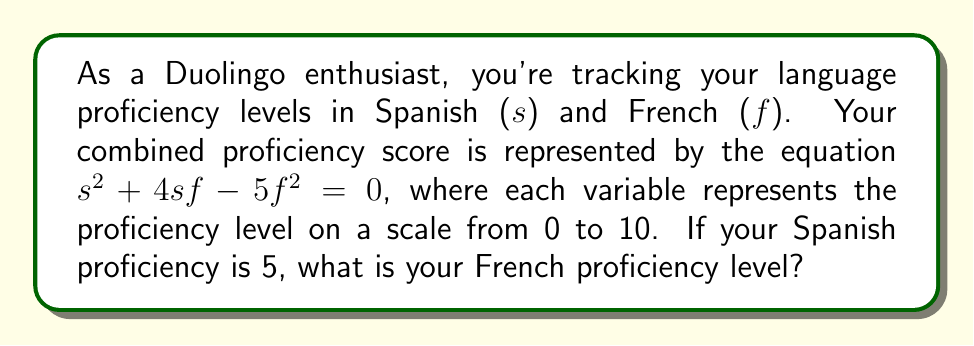Give your solution to this math problem. Let's solve this step-by-step:

1) We're given that $s = 5$ (Spanish proficiency), and we need to find $f$ (French proficiency).

2) Substitute $s = 5$ into the equation:
   $$(5)^2 + 4(5)f - 5f^2 = 0$$

3) Simplify:
   $$25 + 20f - 5f^2 = 0$$

4) Rearrange to standard form:
   $$-5f^2 + 20f + 25 = 0$$

5) Divide everything by -5 to make the leading coefficient 1:
   $$f^2 - 4f - 5 = 0$$

6) This is a quadratic equation in the form $ax^2 + bx + c = 0$, where $a=1$, $b=-4$, and $c=-5$.

7) We can solve this using the quadratic formula: $x = \frac{-b \pm \sqrt{b^2 - 4ac}}{2a}$

8) Substituting our values:
   $$f = \frac{-(-4) \pm \sqrt{(-4)^2 - 4(1)(-5)}}{2(1)}$$

9) Simplify:
   $$f = \frac{4 \pm \sqrt{16 + 20}}{2} = \frac{4 \pm \sqrt{36}}{2} = \frac{4 \pm 6}{2}$$

10) This gives us two solutions:
    $$f = \frac{4 + 6}{2} = 5$$ or $$f = \frac{4 - 6}{2} = -1$$

11) Since proficiency levels are on a scale from 0 to 10, we discard the negative solution.

Therefore, your French proficiency level is 5.
Answer: 5 